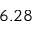<formula> <loc_0><loc_0><loc_500><loc_500>6 . 2 8</formula> 